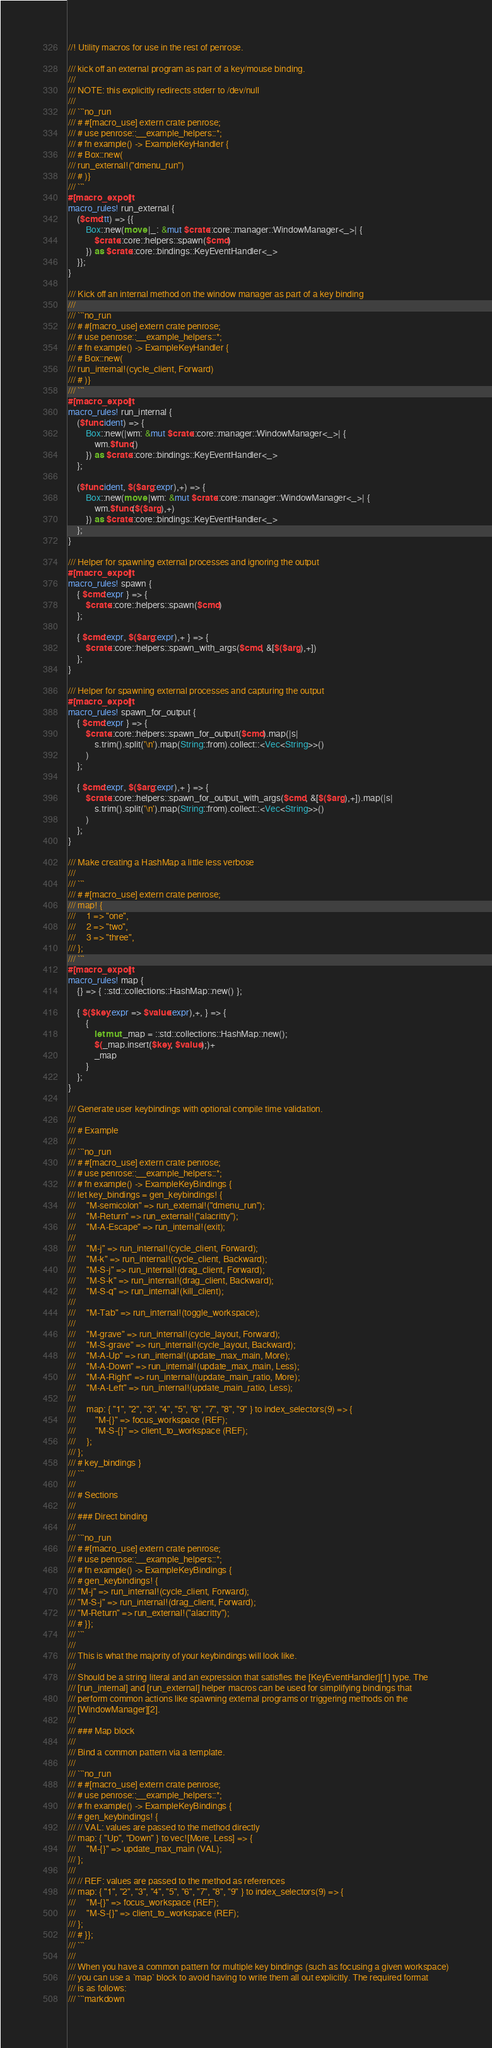<code> <loc_0><loc_0><loc_500><loc_500><_Rust_>//! Utility macros for use in the rest of penrose.

/// kick off an external program as part of a key/mouse binding.
///
/// NOTE: this explicitly redirects stderr to /dev/null
///
/// ```no_run
/// # #[macro_use] extern crate penrose;
/// # use penrose::__example_helpers::*;
/// # fn example() -> ExampleKeyHandler {
/// # Box::new(
/// run_external!("dmenu_run")
/// # )}
/// ```
#[macro_export]
macro_rules! run_external {
    ($cmd:tt) => {{
        Box::new(move |_: &mut $crate::core::manager::WindowManager<_>| {
            $crate::core::helpers::spawn($cmd)
        }) as $crate::core::bindings::KeyEventHandler<_>
    }};
}

/// Kick off an internal method on the window manager as part of a key binding
///
/// ```no_run
/// # #[macro_use] extern crate penrose;
/// # use penrose::__example_helpers::*;
/// # fn example() -> ExampleKeyHandler {
/// # Box::new(
/// run_internal!(cycle_client, Forward)
/// # )}
/// ```
#[macro_export]
macro_rules! run_internal {
    ($func:ident) => {
        Box::new(|wm: &mut $crate::core::manager::WindowManager<_>| {
            wm.$func()
        }) as $crate::core::bindings::KeyEventHandler<_>
    };

    ($func:ident, $($arg:expr),+) => {
        Box::new(move |wm: &mut $crate::core::manager::WindowManager<_>| {
            wm.$func($($arg),+)
        }) as $crate::core::bindings::KeyEventHandler<_>
    };
}

/// Helper for spawning external processes and ignoring the output
#[macro_export]
macro_rules! spawn {
    { $cmd:expr } => {
        $crate::core::helpers::spawn($cmd)
    };

    { $cmd:expr, $($arg:expr),+ } => {
        $crate::core::helpers::spawn_with_args($cmd, &[$($arg),+])
    };
}

/// Helper for spawning external processes and capturing the output
#[macro_export]
macro_rules! spawn_for_output {
    { $cmd:expr } => {
        $crate::core::helpers::spawn_for_output($cmd).map(|s|
            s.trim().split('\n').map(String::from).collect::<Vec<String>>()
        )
    };

    { $cmd:expr, $($arg:expr),+ } => {
        $crate::core::helpers::spawn_for_output_with_args($cmd, &[$($arg),+]).map(|s|
            s.trim().split('\n').map(String::from).collect::<Vec<String>>()
        )
    };
}

/// Make creating a HashMap a little less verbose
///
/// ```
/// # #[macro_use] extern crate penrose;
/// map! {
///     1 => "one",
///     2 => "two",
///     3 => "three",
/// };
/// ```
#[macro_export]
macro_rules! map {
    {} => { ::std::collections::HashMap::new() };

    { $($key:expr => $value:expr),+, } => {
        {
            let mut _map = ::std::collections::HashMap::new();
            $(_map.insert($key, $value);)+
            _map
        }
    };
}

/// Generate user keybindings with optional compile time validation.
///
/// # Example
///
/// ```no_run
/// # #[macro_use] extern crate penrose;
/// # use penrose::__example_helpers::*;
/// # fn example() -> ExampleKeyBindings {
/// let key_bindings = gen_keybindings! {
///     "M-semicolon" => run_external!("dmenu_run");
///     "M-Return" => run_external!("alacritty");
///     "M-A-Escape" => run_internal!(exit);
///
///     "M-j" => run_internal!(cycle_client, Forward);
///     "M-k" => run_internal!(cycle_client, Backward);
///     "M-S-j" => run_internal!(drag_client, Forward);
///     "M-S-k" => run_internal!(drag_client, Backward);
///     "M-S-q" => run_internal!(kill_client);
///
///     "M-Tab" => run_internal!(toggle_workspace);
///
///     "M-grave" => run_internal!(cycle_layout, Forward);
///     "M-S-grave" => run_internal!(cycle_layout, Backward);
///     "M-A-Up" => run_internal!(update_max_main, More);
///     "M-A-Down" => run_internal!(update_max_main, Less);
///     "M-A-Right" => run_internal!(update_main_ratio, More);
///     "M-A-Left" => run_internal!(update_main_ratio, Less);
///
///     map: { "1", "2", "3", "4", "5", "6", "7", "8", "9" } to index_selectors(9) => {
///         "M-{}" => focus_workspace (REF);
///         "M-S-{}" => client_to_workspace (REF);
///     };
/// };
/// # key_bindings }
/// ```
///
/// # Sections
///
/// ### Direct binding
///
/// ```no_run
/// # #[macro_use] extern crate penrose;
/// # use penrose::__example_helpers::*;
/// # fn example() -> ExampleKeyBindings {
/// # gen_keybindings! {
/// "M-j" => run_internal!(cycle_client, Forward);
/// "M-S-j" => run_internal!(drag_client, Forward);
/// "M-Return" => run_external!("alacritty");
/// # }};
/// ```
///
/// This is what the majority of your keybindings will look like.
///
/// Should be a string literal and an expression that satisfies the [KeyEventHandler][1] type. The
/// [run_internal] and [run_external] helper macros can be used for simplifying bindings that
/// perform common actions like spawning external programs or triggering methods on the
/// [WindowManager][2].
///
/// ### Map block
///
/// Bind a common pattern via a template.
///
/// ```no_run
/// # #[macro_use] extern crate penrose;
/// # use penrose::__example_helpers::*;
/// # fn example() -> ExampleKeyBindings {
/// # gen_keybindings! {
/// // VAL: values are passed to the method directly
/// map: { "Up", "Down" } to vec![More, Less] => {
///     "M-{}" => update_max_main (VAL);
/// };
///
/// // REF: values are passed to the method as references
/// map: { "1", "2", "3", "4", "5", "6", "7", "8", "9" } to index_selectors(9) => {
///     "M-{}" => focus_workspace (REF);
///     "M-S-{}" => client_to_workspace (REF);
/// };
/// # }};
/// ```
///
/// When you have a common pattern for multiple key bindings (such as focusing a given workspace)
/// you can use a `map` block to avoid having to write them all out explicitly. The required format
/// is as follows:
/// ```markdown</code> 